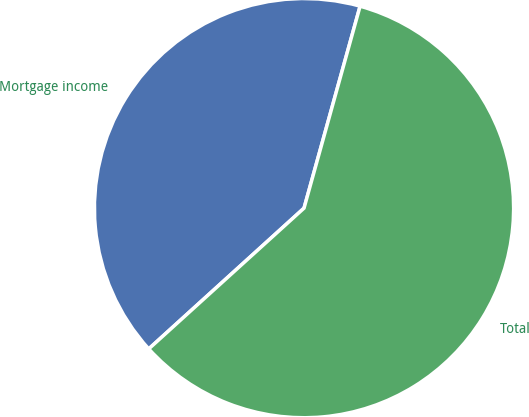Convert chart. <chart><loc_0><loc_0><loc_500><loc_500><pie_chart><fcel>Mortgage income<fcel>Total<nl><fcel>41.03%<fcel>58.97%<nl></chart> 